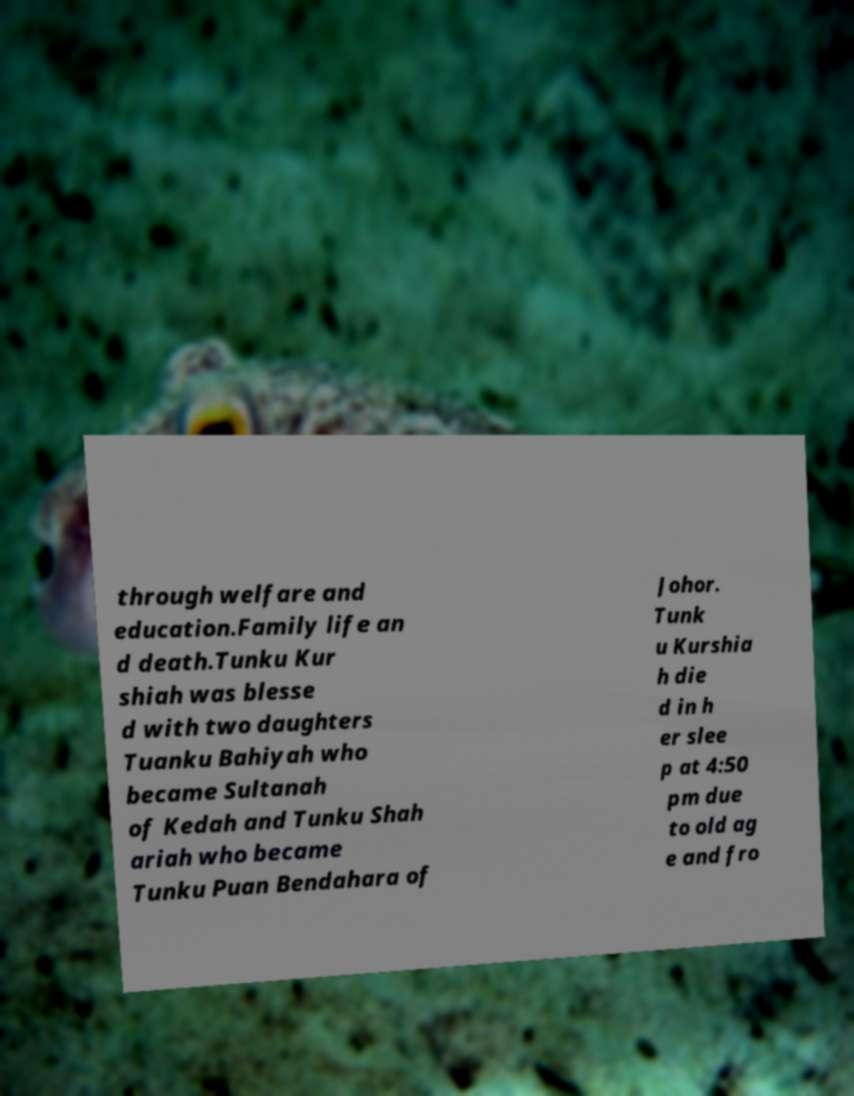Please read and relay the text visible in this image. What does it say? through welfare and education.Family life an d death.Tunku Kur shiah was blesse d with two daughters Tuanku Bahiyah who became Sultanah of Kedah and Tunku Shah ariah who became Tunku Puan Bendahara of Johor. Tunk u Kurshia h die d in h er slee p at 4:50 pm due to old ag e and fro 